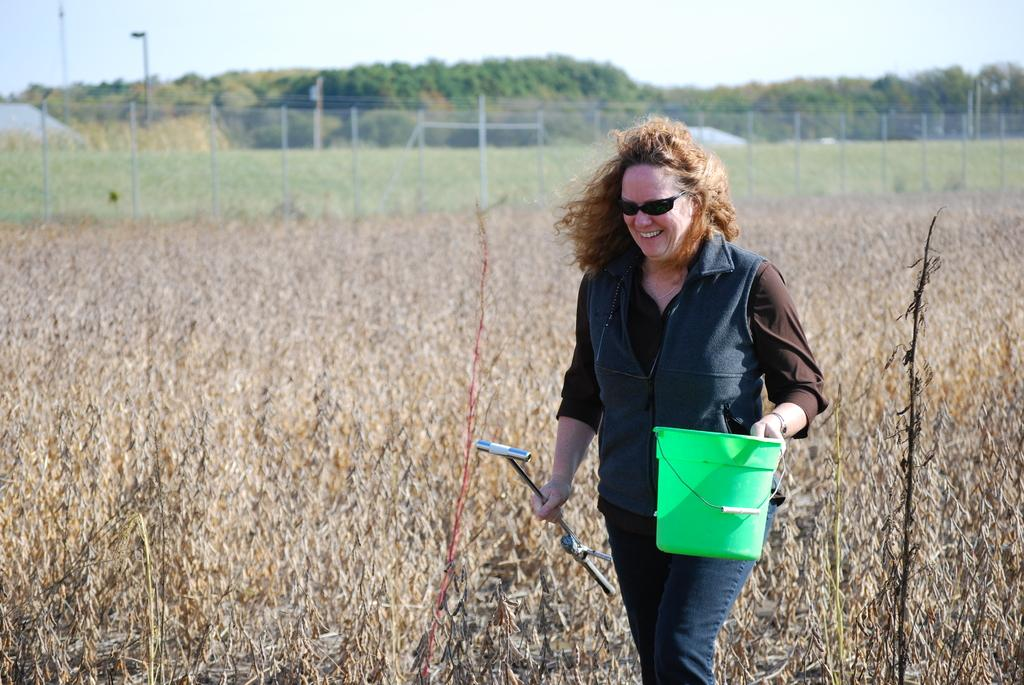Who is present in the image? There is a woman in the image. What is the woman doing in the image? The woman is walking and smiling. What is the woman holding in the image? The woman is holding a bucket and another object. What can be seen in the image besides the woman? There are plants, a fence, trees, poles, and the sky visible in the image. What type of coat is the woman wearing in the image? There is no mention of a coat in the image; the woman is not wearing one. What color is the skirt the woman is wearing in the image? There is no mention of a skirt in the image; the woman is not wearing one. 